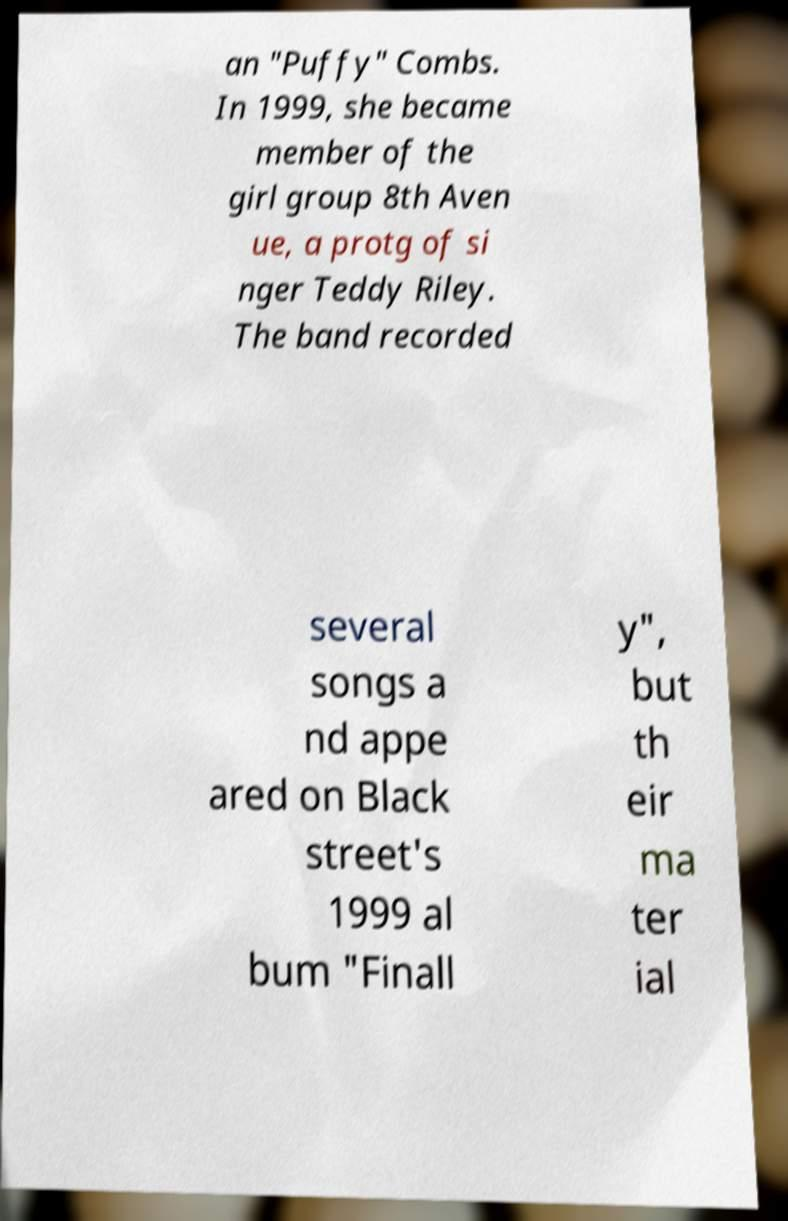For documentation purposes, I need the text within this image transcribed. Could you provide that? an "Puffy" Combs. In 1999, she became member of the girl group 8th Aven ue, a protg of si nger Teddy Riley. The band recorded several songs a nd appe ared on Black street's 1999 al bum "Finall y", but th eir ma ter ial 